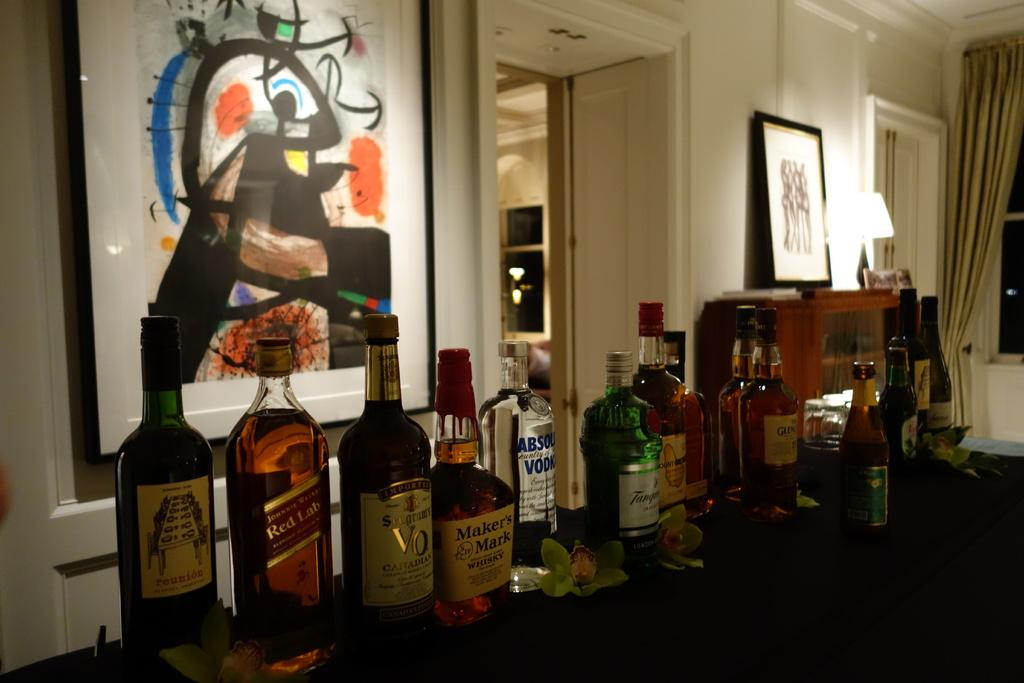Provide a one-sentence caption for the provided image. Bottles of Makers Mark, Absolut Vodka, Red Label and other liquors are lined up on a table. 